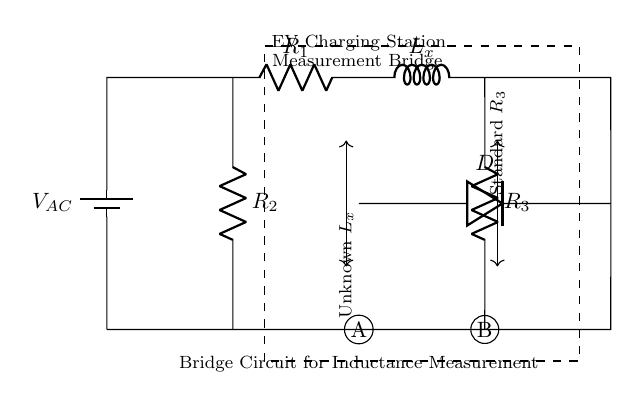What is the voltage source in this circuit? The circuit shows a battery labeled as V_AC, which represents the alternating current voltage source for the bridge.
Answer: V_AC What components are used in the circuit? The components visible in the circuit are a battery, resistors, an inductor, and a diode. Specifically, there are R1, R2, R3, L_x, and D.
Answer: Battery, resistors, inductor, diode What is the role of the unknown component L_x? L_x is the inductor whose inductance is to be measured using this bridge circuit. It is placed in the position of the unknown component in the measurement.
Answer: Measure inductance What connections are made to points A and B in the circuit? Point A connects to the common ground of the circuit through R2 and point B connects to the bottom of R3. This establishes a path for measuring the voltage across L_x and R3 during the inductance measurement.
Answer: R2 and R3 connections How does this circuit measure inductance? The circuit measures inductance by balancing the bridge, allowing the voltage across L_x to be compared with known resistances R2 and R3. This is achieved through the use of a diode and ensuring that voltage conditions satisfy the bridge condition for zero current through the diode.
Answer: Bridge balance method 